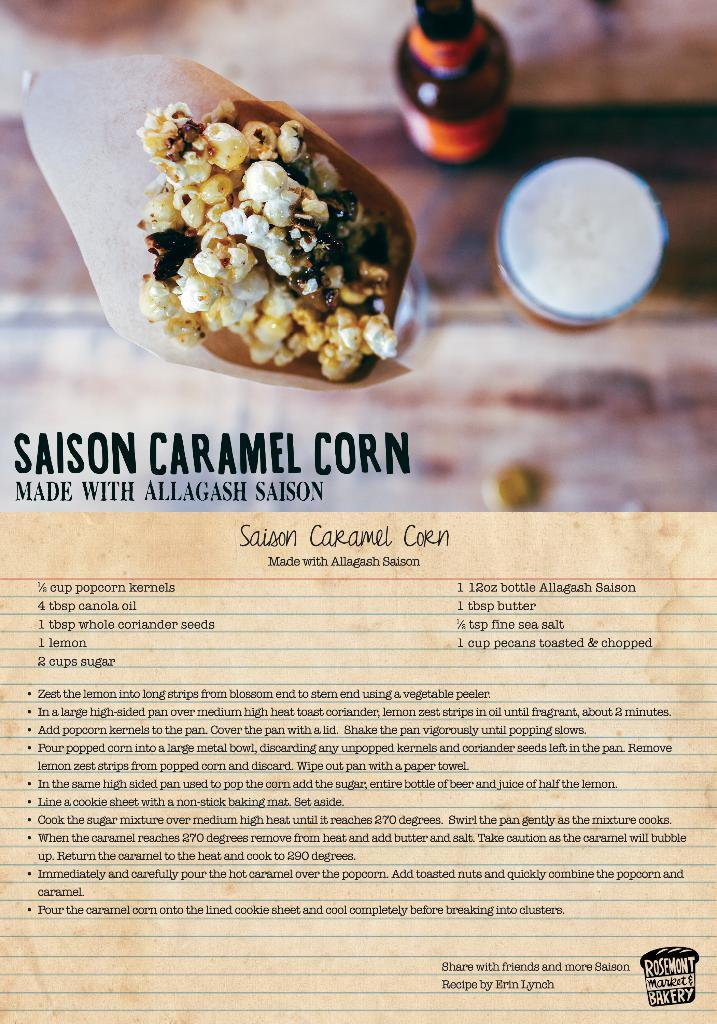Provide a one-sentence caption for the provided image. A recipe page is courtesy of an establishment known as Rosemont Market & Bakery. 